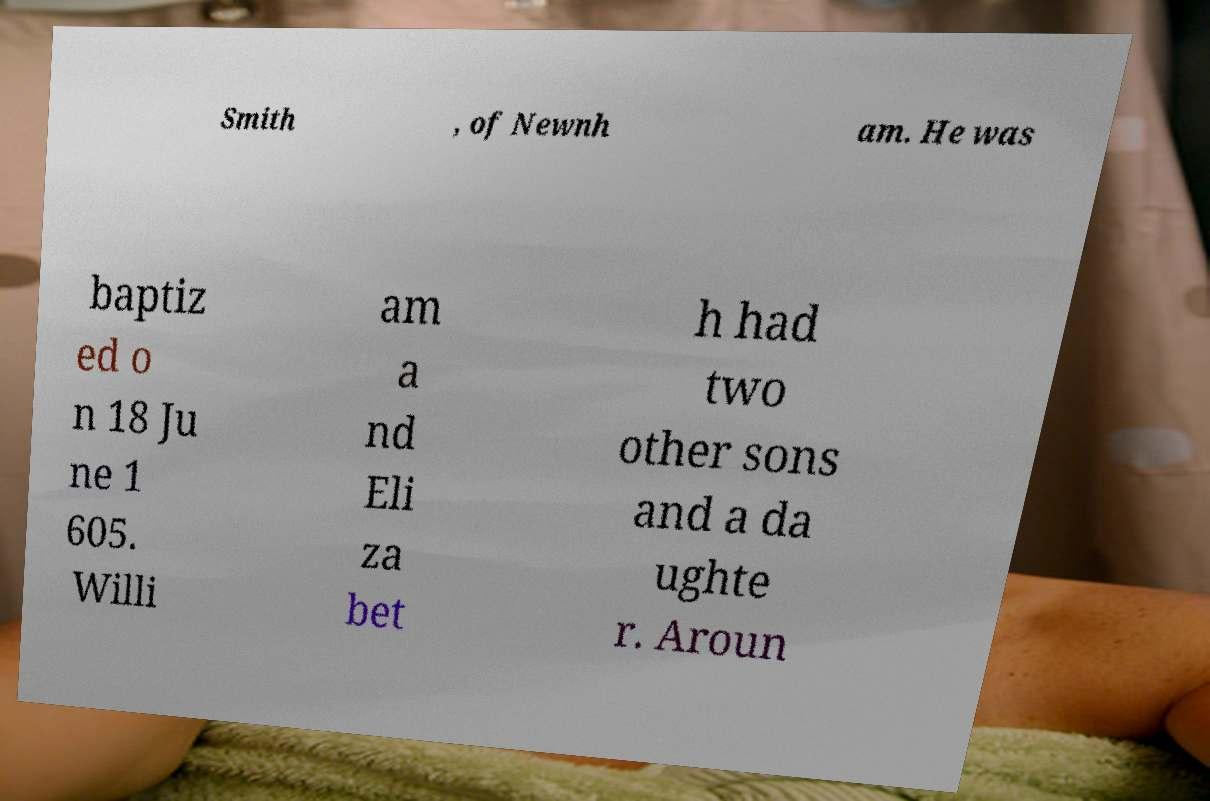There's text embedded in this image that I need extracted. Can you transcribe it verbatim? Smith , of Newnh am. He was baptiz ed o n 18 Ju ne 1 605. Willi am a nd Eli za bet h had two other sons and a da ughte r. Aroun 